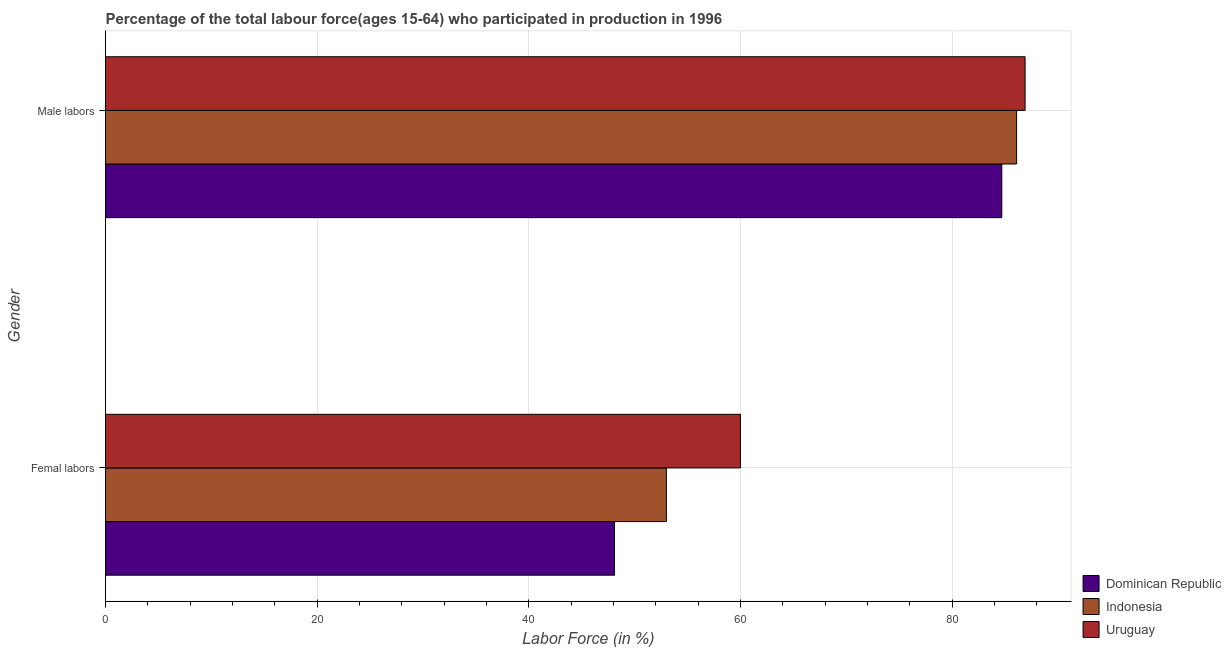How many groups of bars are there?
Ensure brevity in your answer.  2. Are the number of bars on each tick of the Y-axis equal?
Your response must be concise. Yes. What is the label of the 1st group of bars from the top?
Ensure brevity in your answer.  Male labors. What is the percentage of female labor force in Dominican Republic?
Your response must be concise. 48.1. Across all countries, what is the maximum percentage of male labour force?
Provide a succinct answer. 86.9. Across all countries, what is the minimum percentage of female labor force?
Provide a succinct answer. 48.1. In which country was the percentage of male labour force maximum?
Offer a terse response. Uruguay. In which country was the percentage of female labor force minimum?
Ensure brevity in your answer.  Dominican Republic. What is the total percentage of female labor force in the graph?
Give a very brief answer. 161.1. What is the difference between the percentage of male labour force in Uruguay and that in Dominican Republic?
Keep it short and to the point. 2.2. What is the difference between the percentage of female labor force in Dominican Republic and the percentage of male labour force in Uruguay?
Offer a very short reply. -38.8. What is the average percentage of male labour force per country?
Your answer should be compact. 85.9. What is the difference between the percentage of female labor force and percentage of male labour force in Uruguay?
Provide a succinct answer. -26.9. What is the ratio of the percentage of female labor force in Indonesia to that in Dominican Republic?
Your answer should be compact. 1.1. What does the 3rd bar from the top in Male labors represents?
Ensure brevity in your answer.  Dominican Republic. What does the 3rd bar from the bottom in Femal labors represents?
Offer a terse response. Uruguay. How many bars are there?
Offer a terse response. 6. What is the difference between two consecutive major ticks on the X-axis?
Provide a short and direct response. 20. Does the graph contain any zero values?
Keep it short and to the point. No. Does the graph contain grids?
Provide a succinct answer. Yes. Where does the legend appear in the graph?
Ensure brevity in your answer.  Bottom right. How many legend labels are there?
Give a very brief answer. 3. What is the title of the graph?
Provide a short and direct response. Percentage of the total labour force(ages 15-64) who participated in production in 1996. What is the label or title of the X-axis?
Your response must be concise. Labor Force (in %). What is the Labor Force (in %) in Dominican Republic in Femal labors?
Your answer should be very brief. 48.1. What is the Labor Force (in %) in Indonesia in Femal labors?
Make the answer very short. 53. What is the Labor Force (in %) in Uruguay in Femal labors?
Provide a short and direct response. 60. What is the Labor Force (in %) of Dominican Republic in Male labors?
Your response must be concise. 84.7. What is the Labor Force (in %) of Indonesia in Male labors?
Your response must be concise. 86.1. What is the Labor Force (in %) in Uruguay in Male labors?
Make the answer very short. 86.9. Across all Gender, what is the maximum Labor Force (in %) of Dominican Republic?
Make the answer very short. 84.7. Across all Gender, what is the maximum Labor Force (in %) of Indonesia?
Give a very brief answer. 86.1. Across all Gender, what is the maximum Labor Force (in %) of Uruguay?
Offer a terse response. 86.9. Across all Gender, what is the minimum Labor Force (in %) in Dominican Republic?
Keep it short and to the point. 48.1. What is the total Labor Force (in %) of Dominican Republic in the graph?
Keep it short and to the point. 132.8. What is the total Labor Force (in %) of Indonesia in the graph?
Your answer should be very brief. 139.1. What is the total Labor Force (in %) in Uruguay in the graph?
Make the answer very short. 146.9. What is the difference between the Labor Force (in %) in Dominican Republic in Femal labors and that in Male labors?
Provide a succinct answer. -36.6. What is the difference between the Labor Force (in %) in Indonesia in Femal labors and that in Male labors?
Your answer should be very brief. -33.1. What is the difference between the Labor Force (in %) of Uruguay in Femal labors and that in Male labors?
Provide a short and direct response. -26.9. What is the difference between the Labor Force (in %) in Dominican Republic in Femal labors and the Labor Force (in %) in Indonesia in Male labors?
Your answer should be compact. -38. What is the difference between the Labor Force (in %) in Dominican Republic in Femal labors and the Labor Force (in %) in Uruguay in Male labors?
Your answer should be very brief. -38.8. What is the difference between the Labor Force (in %) in Indonesia in Femal labors and the Labor Force (in %) in Uruguay in Male labors?
Provide a succinct answer. -33.9. What is the average Labor Force (in %) in Dominican Republic per Gender?
Provide a short and direct response. 66.4. What is the average Labor Force (in %) of Indonesia per Gender?
Provide a succinct answer. 69.55. What is the average Labor Force (in %) of Uruguay per Gender?
Make the answer very short. 73.45. What is the difference between the Labor Force (in %) of Dominican Republic and Labor Force (in %) of Indonesia in Femal labors?
Offer a very short reply. -4.9. What is the difference between the Labor Force (in %) in Dominican Republic and Labor Force (in %) in Indonesia in Male labors?
Provide a short and direct response. -1.4. What is the ratio of the Labor Force (in %) of Dominican Republic in Femal labors to that in Male labors?
Offer a terse response. 0.57. What is the ratio of the Labor Force (in %) in Indonesia in Femal labors to that in Male labors?
Offer a very short reply. 0.62. What is the ratio of the Labor Force (in %) of Uruguay in Femal labors to that in Male labors?
Give a very brief answer. 0.69. What is the difference between the highest and the second highest Labor Force (in %) in Dominican Republic?
Ensure brevity in your answer.  36.6. What is the difference between the highest and the second highest Labor Force (in %) in Indonesia?
Offer a terse response. 33.1. What is the difference between the highest and the second highest Labor Force (in %) of Uruguay?
Offer a very short reply. 26.9. What is the difference between the highest and the lowest Labor Force (in %) of Dominican Republic?
Your answer should be compact. 36.6. What is the difference between the highest and the lowest Labor Force (in %) in Indonesia?
Your answer should be compact. 33.1. What is the difference between the highest and the lowest Labor Force (in %) of Uruguay?
Provide a succinct answer. 26.9. 